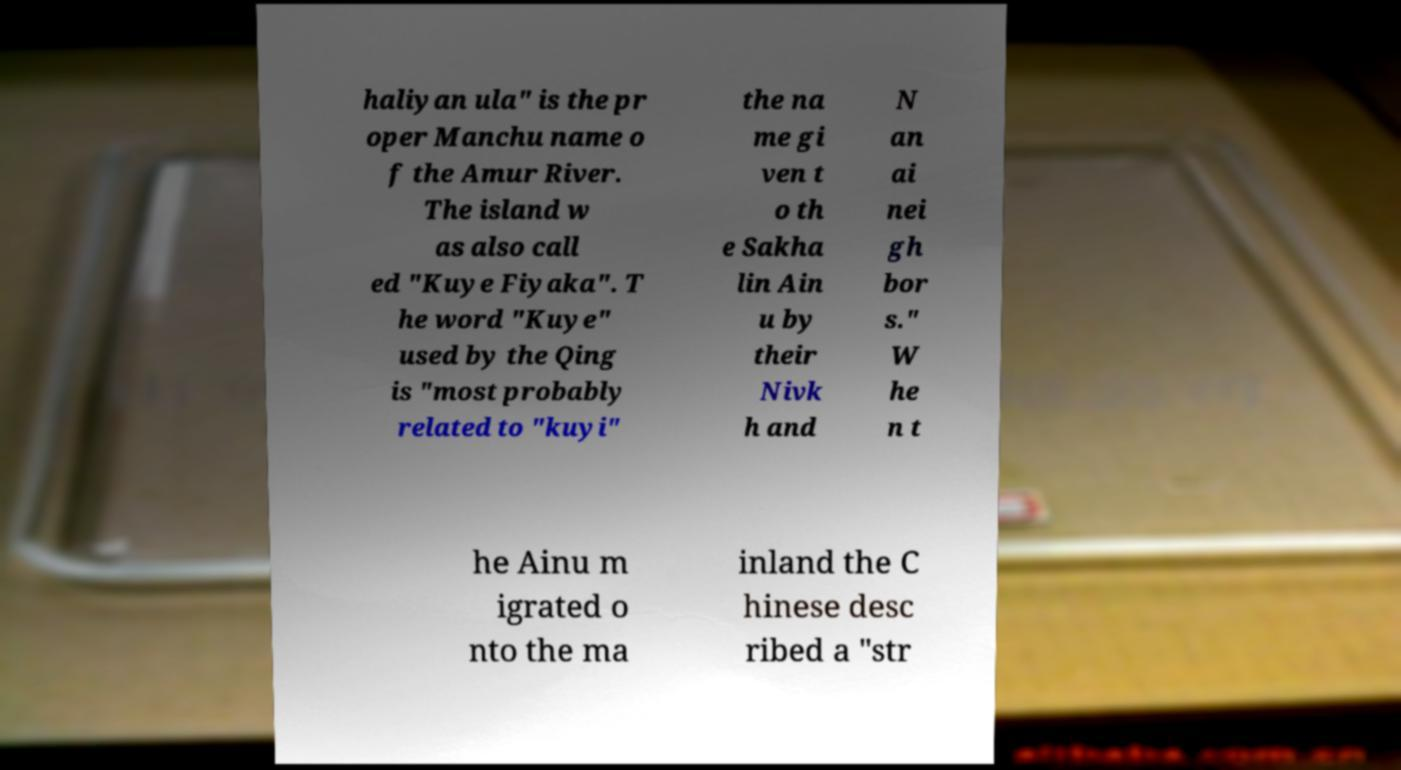Can you read and provide the text displayed in the image?This photo seems to have some interesting text. Can you extract and type it out for me? haliyan ula" is the pr oper Manchu name o f the Amur River. The island w as also call ed "Kuye Fiyaka". T he word "Kuye" used by the Qing is "most probably related to "kuyi" the na me gi ven t o th e Sakha lin Ain u by their Nivk h and N an ai nei gh bor s." W he n t he Ainu m igrated o nto the ma inland the C hinese desc ribed a "str 